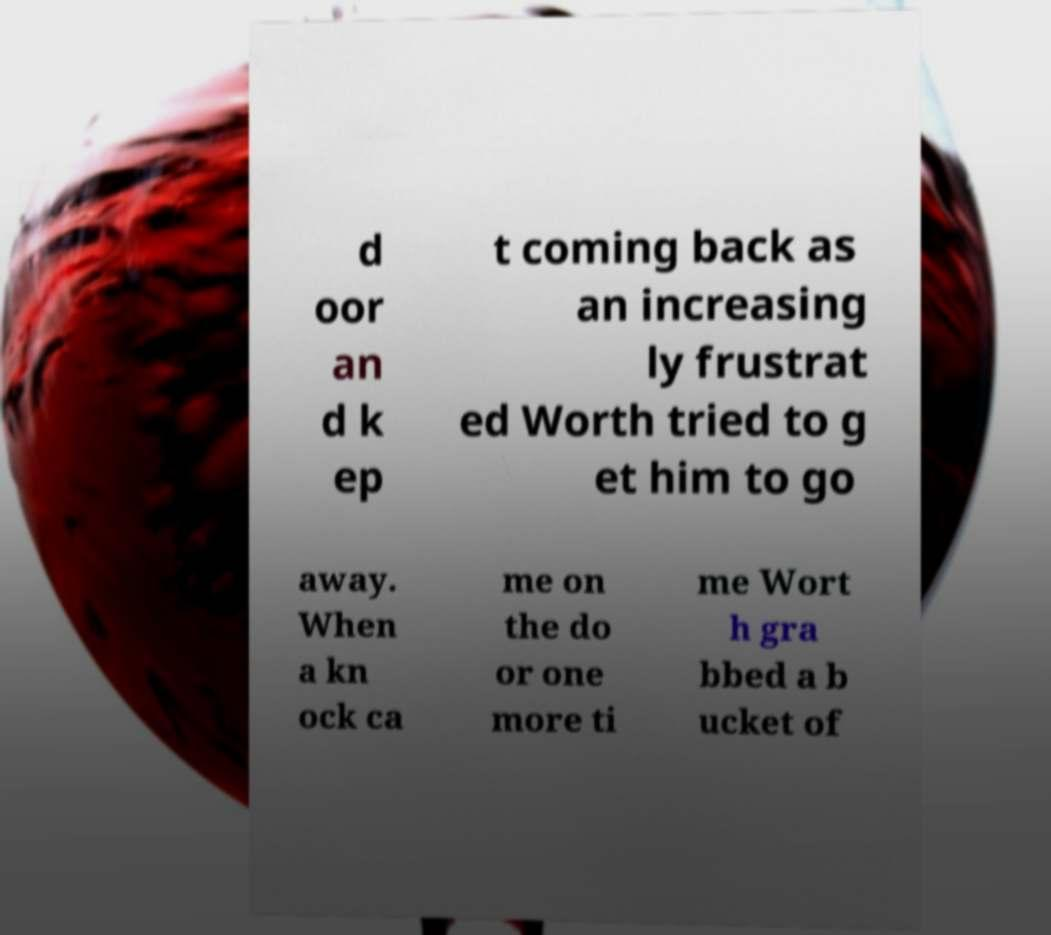Can you accurately transcribe the text from the provided image for me? d oor an d k ep t coming back as an increasing ly frustrat ed Worth tried to g et him to go away. When a kn ock ca me on the do or one more ti me Wort h gra bbed a b ucket of 